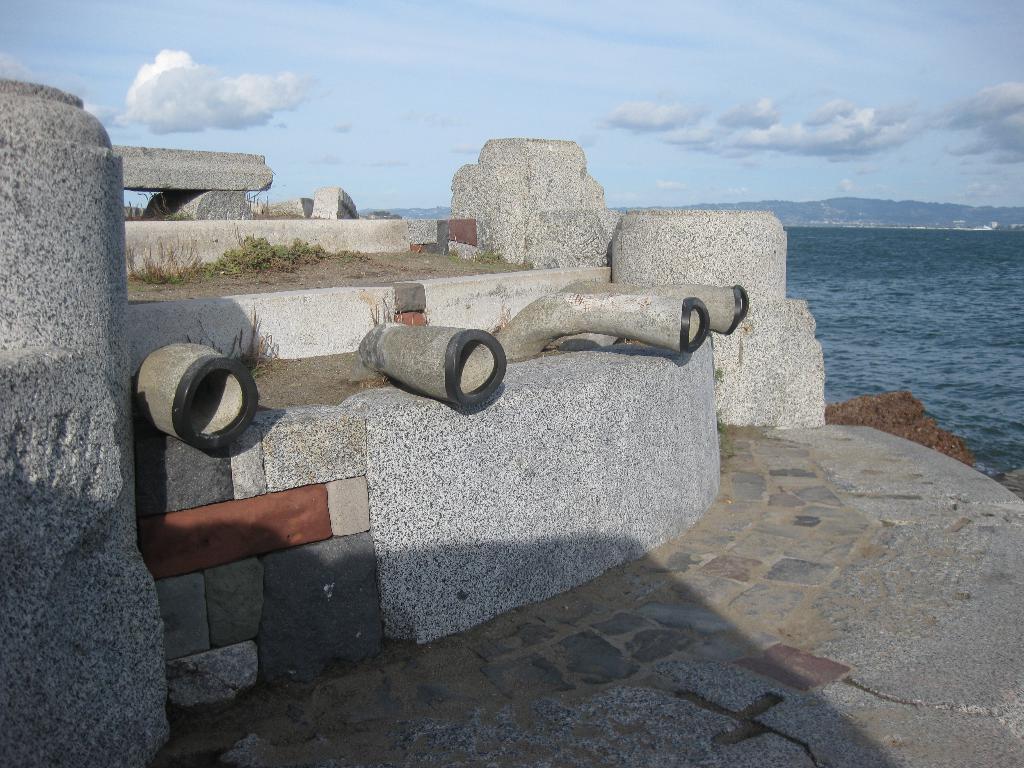In one or two sentences, can you explain what this image depicts? In the picture we can see some concrete and rock construction and some pipes to it and beside it, we can see mud which is brown in color and beside it, we can see the water, which is gray in color and in the background we can see a sky with clouds. 